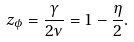Convert formula to latex. <formula><loc_0><loc_0><loc_500><loc_500>z _ { \phi } = \frac { \gamma } { 2 \nu } = 1 - \frac { \eta } { 2 } .</formula> 